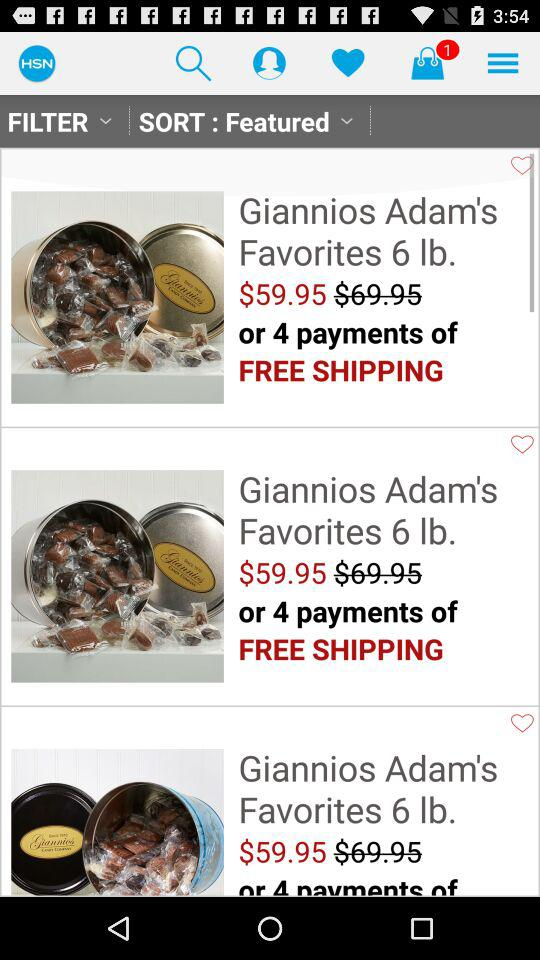What is the price of "Giannios Adam's Favorites 6 lb."? The price of "Giannios Adam's Favorites 6 lb." is $59.95. 